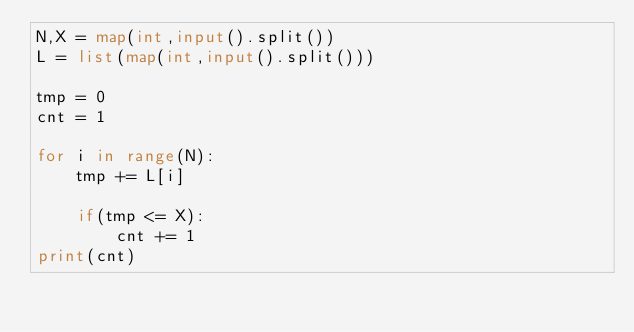Convert code to text. <code><loc_0><loc_0><loc_500><loc_500><_Python_>N,X = map(int,input().split())
L = list(map(int,input().split()))

tmp = 0
cnt = 1

for i in range(N):
    tmp += L[i]

    if(tmp <= X):
        cnt += 1
print(cnt)</code> 